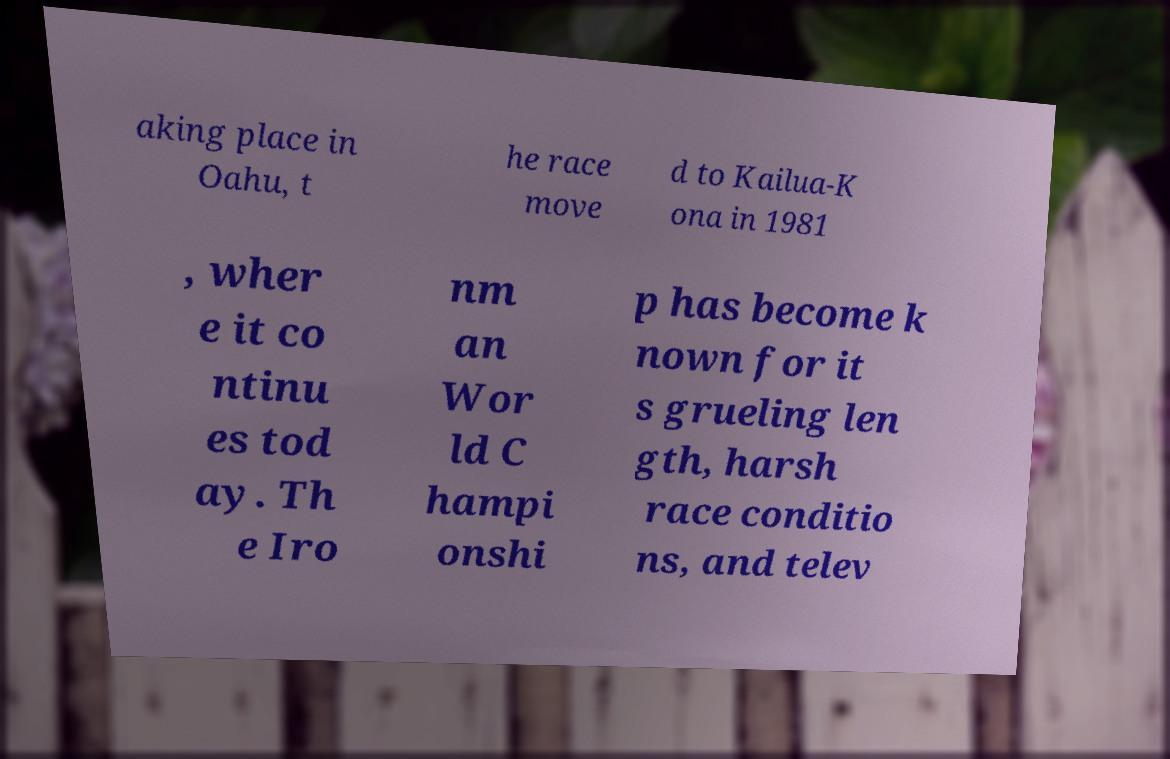I need the written content from this picture converted into text. Can you do that? aking place in Oahu, t he race move d to Kailua-K ona in 1981 , wher e it co ntinu es tod ay. Th e Iro nm an Wor ld C hampi onshi p has become k nown for it s grueling len gth, harsh race conditio ns, and telev 